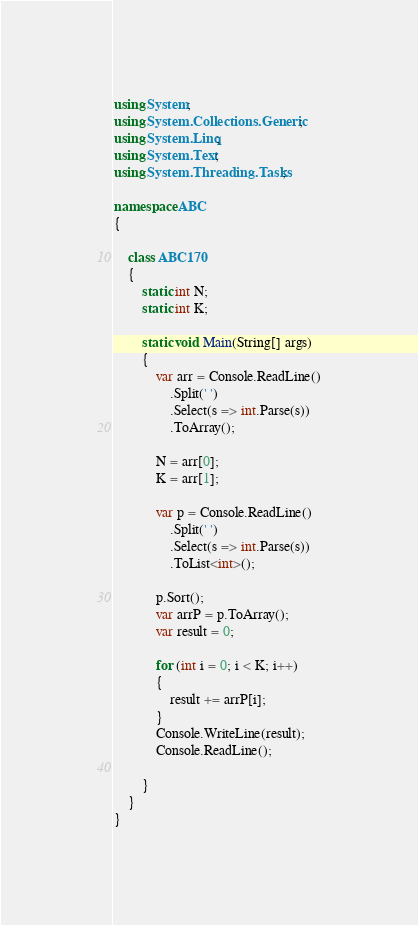Convert code to text. <code><loc_0><loc_0><loc_500><loc_500><_C#_>using System;
using System.Collections.Generic;
using System.Linq;
using System.Text;
using System.Threading.Tasks;

namespace ABC
{

    class ABC170
    {
        static int N;
        static int K;

        static void Main(String[] args)
        {
            var arr = Console.ReadLine()
                .Split(' ')
                .Select(s => int.Parse(s))
                .ToArray();

            N = arr[0];
            K = arr[1];

            var p = Console.ReadLine()
                .Split(' ')
                .Select(s => int.Parse(s))
                .ToList<int>();

            p.Sort();
            var arrP = p.ToArray();
            var result = 0;

            for (int i = 0; i < K; i++)
            {
                result += arrP[i];
            }
            Console.WriteLine(result);
            Console.ReadLine();

        }
    }
}
</code> 